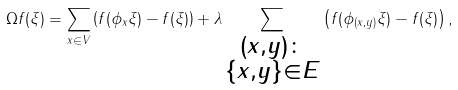<formula> <loc_0><loc_0><loc_500><loc_500>\Omega f ( \xi ) = \sum _ { x \in V } \left ( f ( \phi _ { x } \xi ) - f ( \xi ) \right ) + \lambda \sum _ { \substack { { ( x , y ) \colon } \\ { \{ x , y \} \in E } } } \left ( f ( \phi _ { ( x , y ) } \xi ) - f ( \xi ) \right ) ,</formula> 